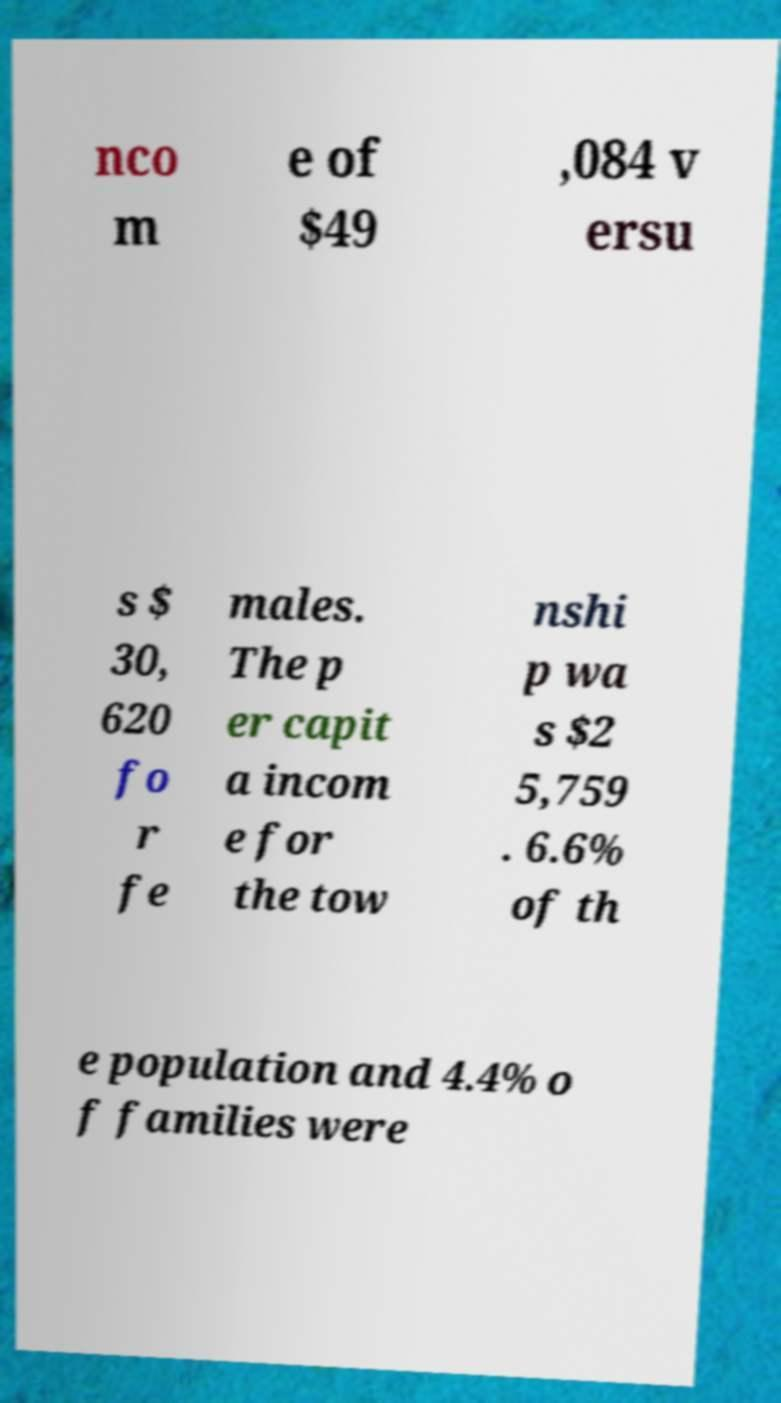What messages or text are displayed in this image? I need them in a readable, typed format. nco m e of $49 ,084 v ersu s $ 30, 620 fo r fe males. The p er capit a incom e for the tow nshi p wa s $2 5,759 . 6.6% of th e population and 4.4% o f families were 